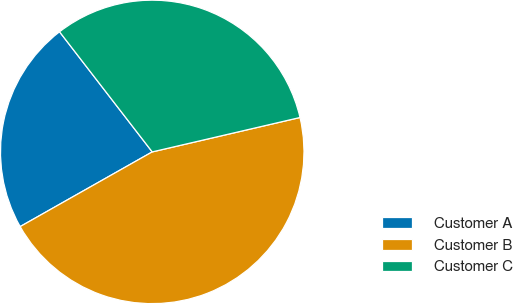Convert chart to OTSL. <chart><loc_0><loc_0><loc_500><loc_500><pie_chart><fcel>Customer A<fcel>Customer B<fcel>Customer C<nl><fcel>22.73%<fcel>45.45%<fcel>31.82%<nl></chart> 